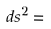<formula> <loc_0><loc_0><loc_500><loc_500>d s ^ { 2 } =</formula> 